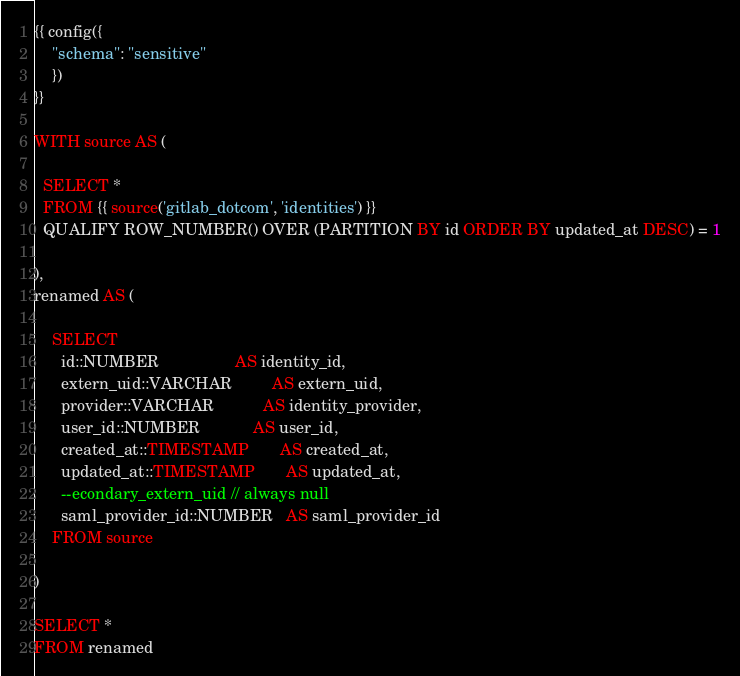Convert code to text. <code><loc_0><loc_0><loc_500><loc_500><_SQL_>{{ config({
    "schema": "sensitive"
    })
}}

WITH source AS (

  SELECT *
  FROM {{ source('gitlab_dotcom', 'identities') }}
  QUALIFY ROW_NUMBER() OVER (PARTITION BY id ORDER BY updated_at DESC) = 1

),
renamed AS (

    SELECT
      id::NUMBER                 AS identity_id,
      extern_uid::VARCHAR         AS extern_uid,
      provider::VARCHAR           AS identity_provider,
      user_id::NUMBER            AS user_id,
      created_at::TIMESTAMP       AS created_at,
      updated_at::TIMESTAMP       AS updated_at,
      --econdary_extern_uid // always null
      saml_provider_id::NUMBER   AS saml_provider_id
    FROM source

)

SELECT *
FROM renamed
</code> 